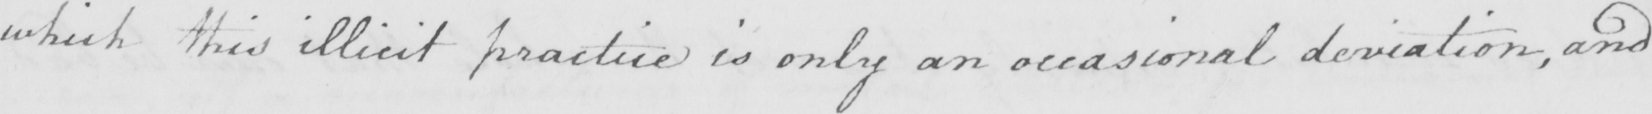Please provide the text content of this handwritten line. which this illicit practise is only an occasional deviation , and 